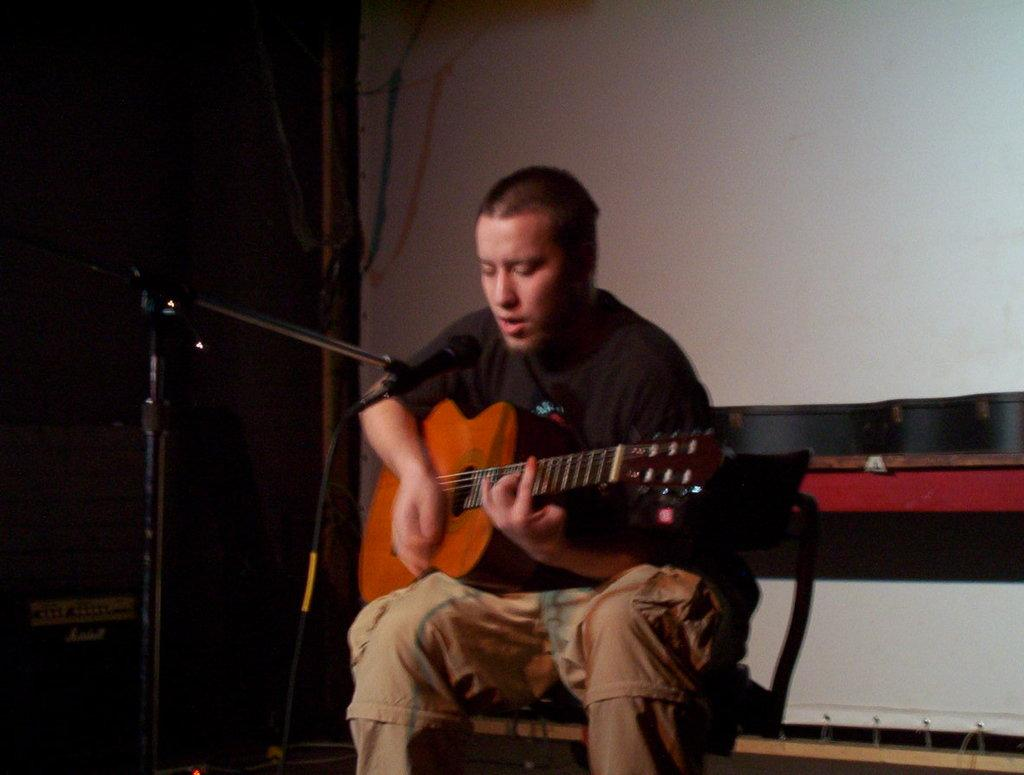Who is the main subject in the image? There is a man in the image. What is the man doing in the image? The man is sitting on a table, holding a guitar, and singing a song. What object is the man using to amplify his voice? There is a microphone in the image, and the man is using it to amplify his voice. What is supporting the microphone? There is a stand for the microphone in the image. What can be seen in the background of the image? The background of the image includes a wall. Where is the sister of the man in the image? There is no mention of a sister in the image or the provided facts. What type of fruit is the man eating in the image? There is no fruit present in the image. 